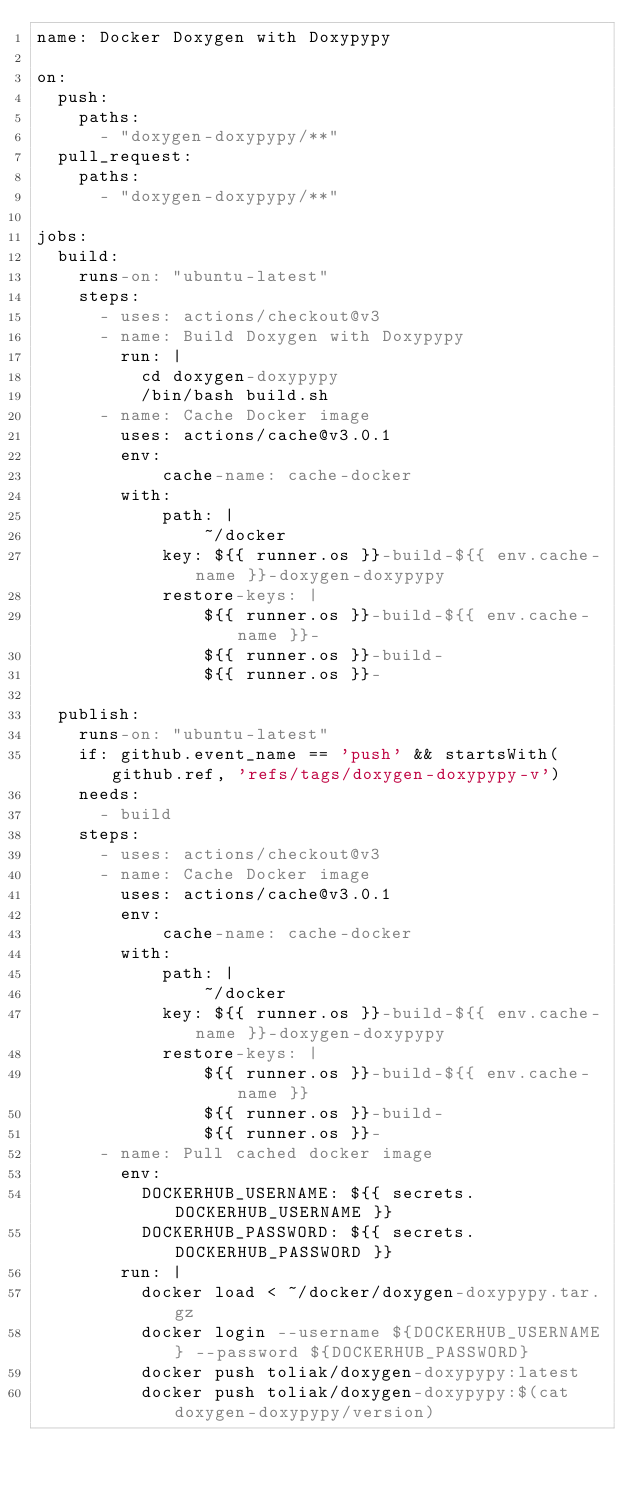<code> <loc_0><loc_0><loc_500><loc_500><_YAML_>name: Docker Doxygen with Doxypypy

on:
  push:
    paths:
      - "doxygen-doxypypy/**"
  pull_request:
    paths:
      - "doxygen-doxypypy/**"

jobs:
  build:
    runs-on: "ubuntu-latest"
    steps:
      - uses: actions/checkout@v3
      - name: Build Doxygen with Doxypypy
        run: |
          cd doxygen-doxypypy
          /bin/bash build.sh
      - name: Cache Docker image
        uses: actions/cache@v3.0.1
        env:
            cache-name: cache-docker
        with:
            path: |
                ~/docker
            key: ${{ runner.os }}-build-${{ env.cache-name }}-doxygen-doxypypy
            restore-keys: |
                ${{ runner.os }}-build-${{ env.cache-name }}-
                ${{ runner.os }}-build-
                ${{ runner.os }}-

  publish:
    runs-on: "ubuntu-latest"
    if: github.event_name == 'push' && startsWith(github.ref, 'refs/tags/doxygen-doxypypy-v')
    needs:
      - build
    steps:
      - uses: actions/checkout@v3
      - name: Cache Docker image
        uses: actions/cache@v3.0.1
        env:
            cache-name: cache-docker
        with:
            path: |
                ~/docker
            key: ${{ runner.os }}-build-${{ env.cache-name }}-doxygen-doxypypy
            restore-keys: |
                ${{ runner.os }}-build-${{ env.cache-name }}
                ${{ runner.os }}-build-
                ${{ runner.os }}-
      - name: Pull cached docker image
        env:
          DOCKERHUB_USERNAME: ${{ secrets.DOCKERHUB_USERNAME }}
          DOCKERHUB_PASSWORD: ${{ secrets.DOCKERHUB_PASSWORD }}
        run: |
          docker load < ~/docker/doxygen-doxypypy.tar.gz
          docker login --username ${DOCKERHUB_USERNAME} --password ${DOCKERHUB_PASSWORD}
          docker push toliak/doxygen-doxypypy:latest
          docker push toliak/doxygen-doxypypy:$(cat doxygen-doxypypy/version)</code> 